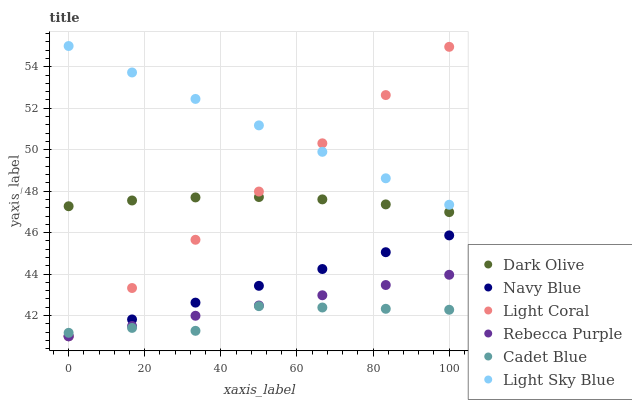Does Cadet Blue have the minimum area under the curve?
Answer yes or no. Yes. Does Light Sky Blue have the maximum area under the curve?
Answer yes or no. Yes. Does Navy Blue have the minimum area under the curve?
Answer yes or no. No. Does Navy Blue have the maximum area under the curve?
Answer yes or no. No. Is Navy Blue the smoothest?
Answer yes or no. Yes. Is Cadet Blue the roughest?
Answer yes or no. Yes. Is Dark Olive the smoothest?
Answer yes or no. No. Is Dark Olive the roughest?
Answer yes or no. No. Does Navy Blue have the lowest value?
Answer yes or no. Yes. Does Dark Olive have the lowest value?
Answer yes or no. No. Does Light Sky Blue have the highest value?
Answer yes or no. Yes. Does Navy Blue have the highest value?
Answer yes or no. No. Is Rebecca Purple less than Light Sky Blue?
Answer yes or no. Yes. Is Dark Olive greater than Rebecca Purple?
Answer yes or no. Yes. Does Light Coral intersect Rebecca Purple?
Answer yes or no. Yes. Is Light Coral less than Rebecca Purple?
Answer yes or no. No. Is Light Coral greater than Rebecca Purple?
Answer yes or no. No. Does Rebecca Purple intersect Light Sky Blue?
Answer yes or no. No. 